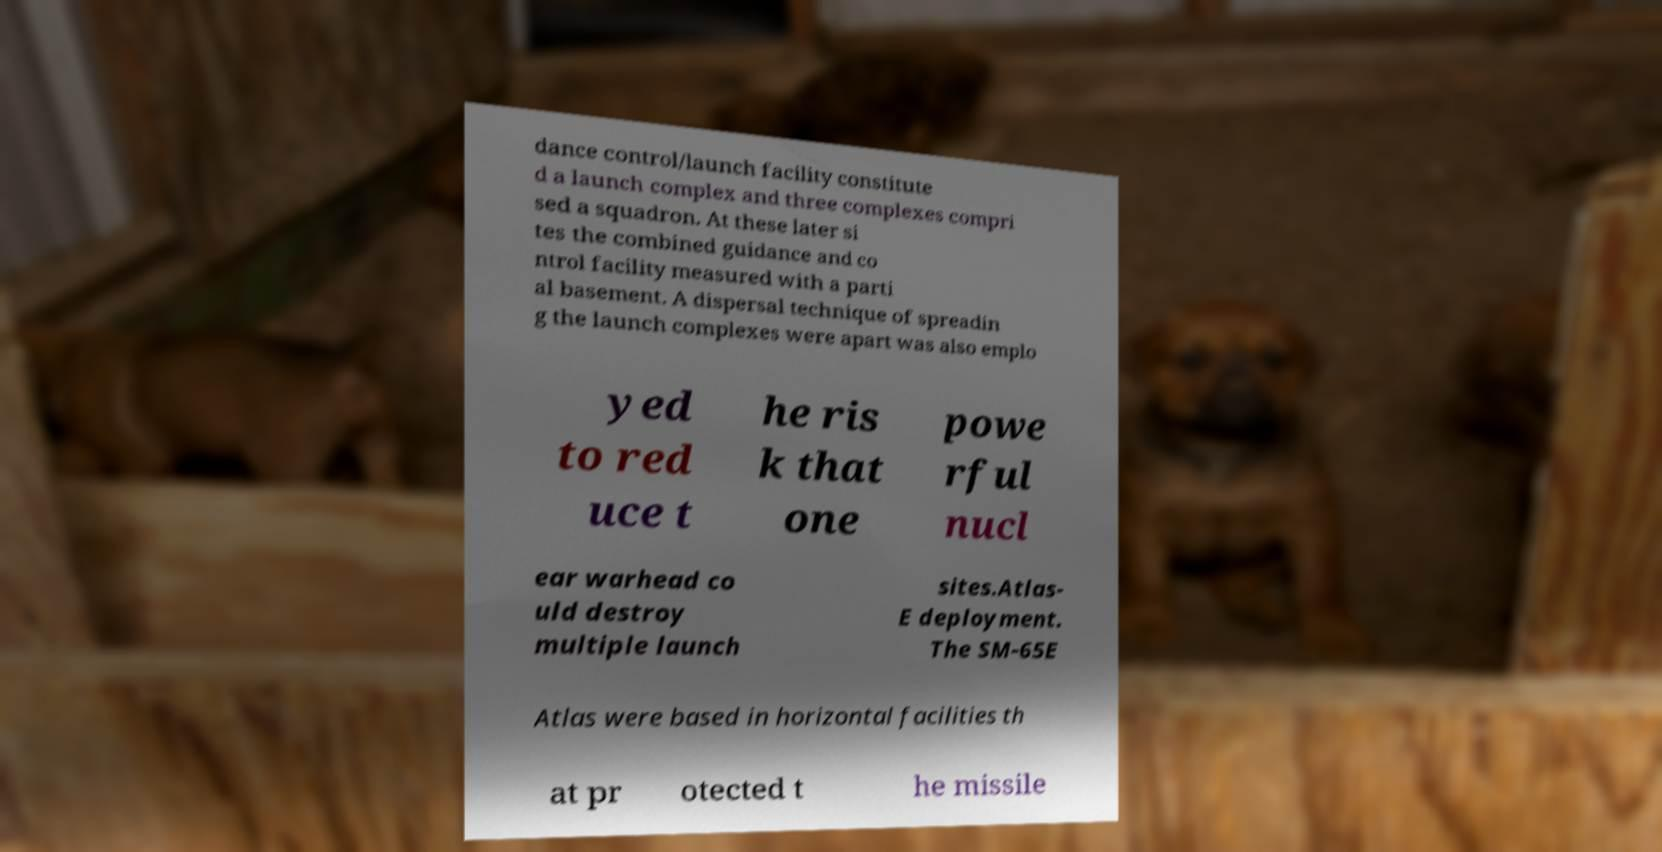I need the written content from this picture converted into text. Can you do that? dance control/launch facility constitute d a launch complex and three complexes compri sed a squadron. At these later si tes the combined guidance and co ntrol facility measured with a parti al basement. A dispersal technique of spreadin g the launch complexes were apart was also emplo yed to red uce t he ris k that one powe rful nucl ear warhead co uld destroy multiple launch sites.Atlas- E deployment. The SM-65E Atlas were based in horizontal facilities th at pr otected t he missile 